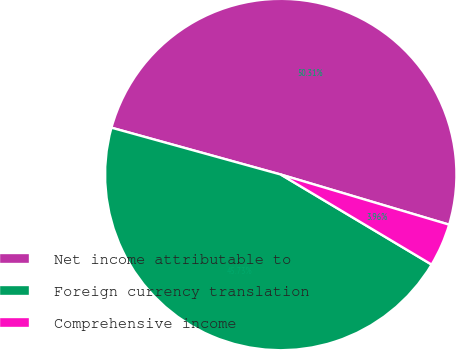Convert chart. <chart><loc_0><loc_0><loc_500><loc_500><pie_chart><fcel>Net income attributable to<fcel>Foreign currency translation<fcel>Comprehensive income<nl><fcel>50.31%<fcel>45.73%<fcel>3.96%<nl></chart> 